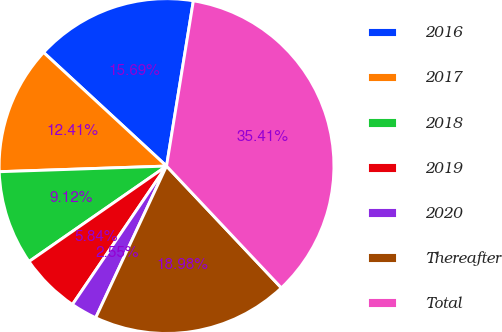Convert chart. <chart><loc_0><loc_0><loc_500><loc_500><pie_chart><fcel>2016<fcel>2017<fcel>2018<fcel>2019<fcel>2020<fcel>Thereafter<fcel>Total<nl><fcel>15.69%<fcel>12.41%<fcel>9.12%<fcel>5.84%<fcel>2.55%<fcel>18.98%<fcel>35.41%<nl></chart> 